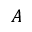Convert formula to latex. <formula><loc_0><loc_0><loc_500><loc_500>A</formula> 